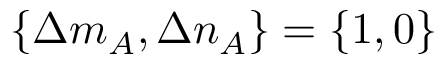<formula> <loc_0><loc_0><loc_500><loc_500>\{ \Delta m _ { A } , \Delta n _ { A } \} = \{ 1 , 0 \}</formula> 